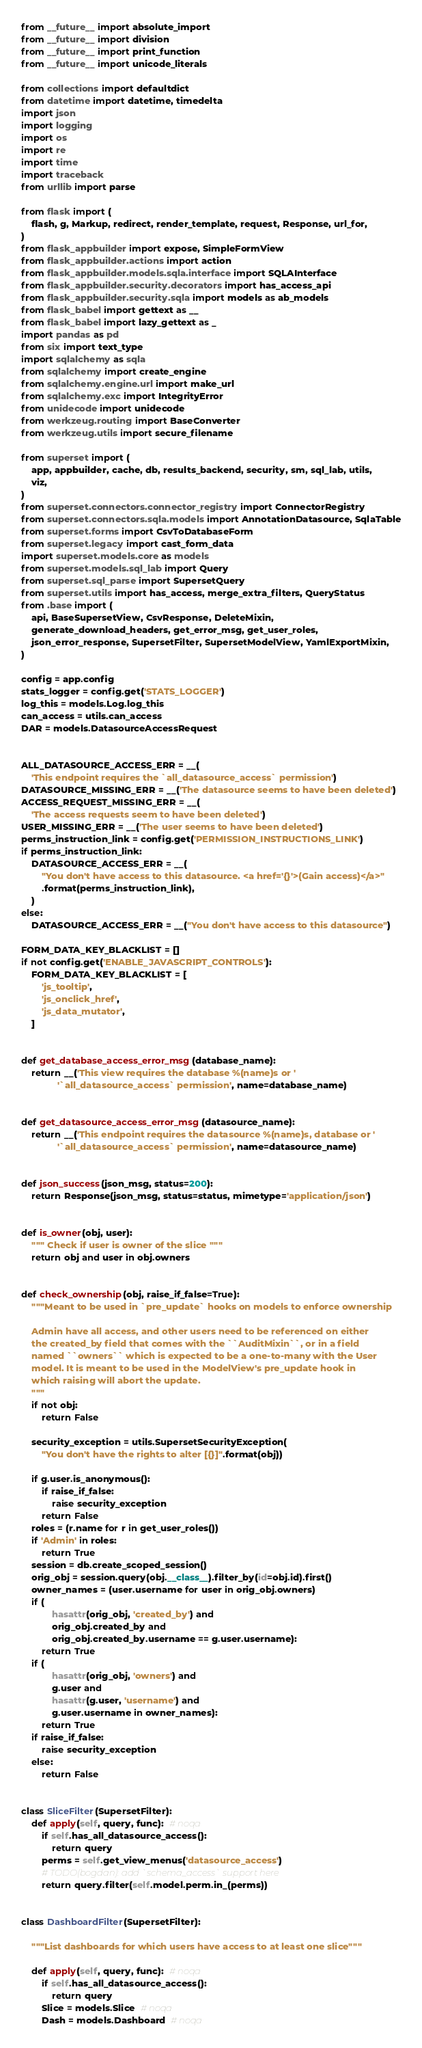Convert code to text. <code><loc_0><loc_0><loc_500><loc_500><_Python_>from __future__ import absolute_import
from __future__ import division
from __future__ import print_function
from __future__ import unicode_literals

from collections import defaultdict
from datetime import datetime, timedelta
import json
import logging
import os
import re
import time
import traceback
from urllib import parse

from flask import (
    flash, g, Markup, redirect, render_template, request, Response, url_for,
)
from flask_appbuilder import expose, SimpleFormView
from flask_appbuilder.actions import action
from flask_appbuilder.models.sqla.interface import SQLAInterface
from flask_appbuilder.security.decorators import has_access_api
from flask_appbuilder.security.sqla import models as ab_models
from flask_babel import gettext as __
from flask_babel import lazy_gettext as _
import pandas as pd
from six import text_type
import sqlalchemy as sqla
from sqlalchemy import create_engine
from sqlalchemy.engine.url import make_url
from sqlalchemy.exc import IntegrityError
from unidecode import unidecode
from werkzeug.routing import BaseConverter
from werkzeug.utils import secure_filename

from superset import (
    app, appbuilder, cache, db, results_backend, security, sm, sql_lab, utils,
    viz,
)
from superset.connectors.connector_registry import ConnectorRegistry
from superset.connectors.sqla.models import AnnotationDatasource, SqlaTable
from superset.forms import CsvToDatabaseForm
from superset.legacy import cast_form_data
import superset.models.core as models
from superset.models.sql_lab import Query
from superset.sql_parse import SupersetQuery
from superset.utils import has_access, merge_extra_filters, QueryStatus
from .base import (
    api, BaseSupersetView, CsvResponse, DeleteMixin,
    generate_download_headers, get_error_msg, get_user_roles,
    json_error_response, SupersetFilter, SupersetModelView, YamlExportMixin,
)

config = app.config
stats_logger = config.get('STATS_LOGGER')
log_this = models.Log.log_this
can_access = utils.can_access
DAR = models.DatasourceAccessRequest


ALL_DATASOURCE_ACCESS_ERR = __(
    'This endpoint requires the `all_datasource_access` permission')
DATASOURCE_MISSING_ERR = __('The datasource seems to have been deleted')
ACCESS_REQUEST_MISSING_ERR = __(
    'The access requests seem to have been deleted')
USER_MISSING_ERR = __('The user seems to have been deleted')
perms_instruction_link = config.get('PERMISSION_INSTRUCTIONS_LINK')
if perms_instruction_link:
    DATASOURCE_ACCESS_ERR = __(
        "You don't have access to this datasource. <a href='{}'>(Gain access)</a>"
        .format(perms_instruction_link),
    )
else:
    DATASOURCE_ACCESS_ERR = __("You don't have access to this datasource")

FORM_DATA_KEY_BLACKLIST = []
if not config.get('ENABLE_JAVASCRIPT_CONTROLS'):
    FORM_DATA_KEY_BLACKLIST = [
        'js_tooltip',
        'js_onclick_href',
        'js_data_mutator',
    ]


def get_database_access_error_msg(database_name):
    return __('This view requires the database %(name)s or '
              '`all_datasource_access` permission', name=database_name)


def get_datasource_access_error_msg(datasource_name):
    return __('This endpoint requires the datasource %(name)s, database or '
              '`all_datasource_access` permission', name=datasource_name)


def json_success(json_msg, status=200):
    return Response(json_msg, status=status, mimetype='application/json')


def is_owner(obj, user):
    """ Check if user is owner of the slice """
    return obj and user in obj.owners


def check_ownership(obj, raise_if_false=True):
    """Meant to be used in `pre_update` hooks on models to enforce ownership

    Admin have all access, and other users need to be referenced on either
    the created_by field that comes with the ``AuditMixin``, or in a field
    named ``owners`` which is expected to be a one-to-many with the User
    model. It is meant to be used in the ModelView's pre_update hook in
    which raising will abort the update.
    """
    if not obj:
        return False

    security_exception = utils.SupersetSecurityException(
        "You don't have the rights to alter [{}]".format(obj))

    if g.user.is_anonymous():
        if raise_if_false:
            raise security_exception
        return False
    roles = (r.name for r in get_user_roles())
    if 'Admin' in roles:
        return True
    session = db.create_scoped_session()
    orig_obj = session.query(obj.__class__).filter_by(id=obj.id).first()
    owner_names = (user.username for user in orig_obj.owners)
    if (
            hasattr(orig_obj, 'created_by') and
            orig_obj.created_by and
            orig_obj.created_by.username == g.user.username):
        return True
    if (
            hasattr(orig_obj, 'owners') and
            g.user and
            hasattr(g.user, 'username') and
            g.user.username in owner_names):
        return True
    if raise_if_false:
        raise security_exception
    else:
        return False


class SliceFilter(SupersetFilter):
    def apply(self, query, func):  # noqa
        if self.has_all_datasource_access():
            return query
        perms = self.get_view_menus('datasource_access')
        # TODO(bogdan): add `schema_access` support here
        return query.filter(self.model.perm.in_(perms))


class DashboardFilter(SupersetFilter):

    """List dashboards for which users have access to at least one slice"""

    def apply(self, query, func):  # noqa
        if self.has_all_datasource_access():
            return query
        Slice = models.Slice  # noqa
        Dash = models.Dashboard  # noqa</code> 